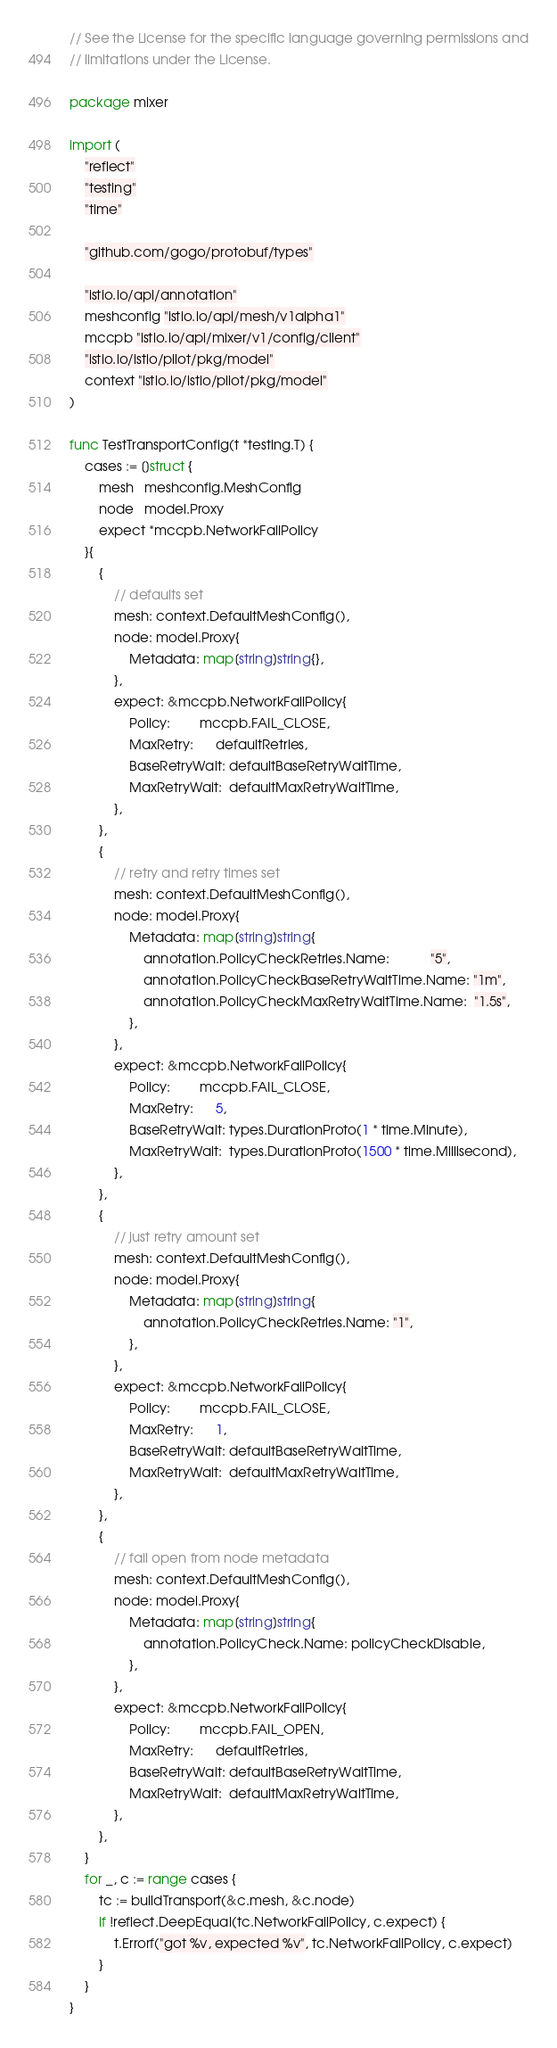Convert code to text. <code><loc_0><loc_0><loc_500><loc_500><_Go_>// See the License for the specific language governing permissions and
// limitations under the License.

package mixer

import (
	"reflect"
	"testing"
	"time"

	"github.com/gogo/protobuf/types"

	"istio.io/api/annotation"
	meshconfig "istio.io/api/mesh/v1alpha1"
	mccpb "istio.io/api/mixer/v1/config/client"
	"istio.io/istio/pilot/pkg/model"
	context "istio.io/istio/pilot/pkg/model"
)

func TestTransportConfig(t *testing.T) {
	cases := []struct {
		mesh   meshconfig.MeshConfig
		node   model.Proxy
		expect *mccpb.NetworkFailPolicy
	}{
		{
			// defaults set
			mesh: context.DefaultMeshConfig(),
			node: model.Proxy{
				Metadata: map[string]string{},
			},
			expect: &mccpb.NetworkFailPolicy{
				Policy:        mccpb.FAIL_CLOSE,
				MaxRetry:      defaultRetries,
				BaseRetryWait: defaultBaseRetryWaitTime,
				MaxRetryWait:  defaultMaxRetryWaitTime,
			},
		},
		{
			// retry and retry times set
			mesh: context.DefaultMeshConfig(),
			node: model.Proxy{
				Metadata: map[string]string{
					annotation.PolicyCheckRetries.Name:           "5",
					annotation.PolicyCheckBaseRetryWaitTime.Name: "1m",
					annotation.PolicyCheckMaxRetryWaitTime.Name:  "1.5s",
				},
			},
			expect: &mccpb.NetworkFailPolicy{
				Policy:        mccpb.FAIL_CLOSE,
				MaxRetry:      5,
				BaseRetryWait: types.DurationProto(1 * time.Minute),
				MaxRetryWait:  types.DurationProto(1500 * time.Millisecond),
			},
		},
		{
			// just retry amount set
			mesh: context.DefaultMeshConfig(),
			node: model.Proxy{
				Metadata: map[string]string{
					annotation.PolicyCheckRetries.Name: "1",
				},
			},
			expect: &mccpb.NetworkFailPolicy{
				Policy:        mccpb.FAIL_CLOSE,
				MaxRetry:      1,
				BaseRetryWait: defaultBaseRetryWaitTime,
				MaxRetryWait:  defaultMaxRetryWaitTime,
			},
		},
		{
			// fail open from node metadata
			mesh: context.DefaultMeshConfig(),
			node: model.Proxy{
				Metadata: map[string]string{
					annotation.PolicyCheck.Name: policyCheckDisable,
				},
			},
			expect: &mccpb.NetworkFailPolicy{
				Policy:        mccpb.FAIL_OPEN,
				MaxRetry:      defaultRetries,
				BaseRetryWait: defaultBaseRetryWaitTime,
				MaxRetryWait:  defaultMaxRetryWaitTime,
			},
		},
	}
	for _, c := range cases {
		tc := buildTransport(&c.mesh, &c.node)
		if !reflect.DeepEqual(tc.NetworkFailPolicy, c.expect) {
			t.Errorf("got %v, expected %v", tc.NetworkFailPolicy, c.expect)
		}
	}
}
</code> 